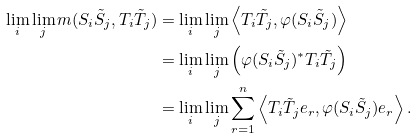Convert formula to latex. <formula><loc_0><loc_0><loc_500><loc_500>\lim _ { i } \lim _ { j } m ( S _ { i } \tilde { S } _ { j } , T _ { i } \tilde { T } _ { j } ) & = \lim _ { i } \lim _ { j } \left < T _ { i } \tilde { T } _ { j } , \varphi ( S _ { i } \tilde { S } _ { j } ) \right > \\ & = \lim _ { i } \lim _ { j } \left ( \varphi ( S _ { i } \tilde { S } _ { j } ) ^ { * } T _ { i } \tilde { T } _ { j } \right ) \\ & = \lim _ { i } \lim _ { j } \sum _ { r = 1 } ^ { n } \left < T _ { i } \tilde { T } _ { j } e _ { r } , \varphi ( S _ { i } \tilde { S } _ { j } ) e _ { r } \right > .</formula> 